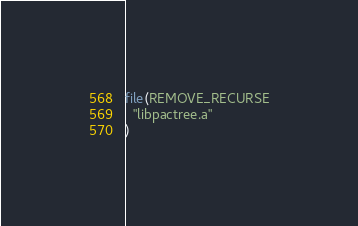Convert code to text. <code><loc_0><loc_0><loc_500><loc_500><_CMake_>file(REMOVE_RECURSE
  "libpactree.a"
)
</code> 